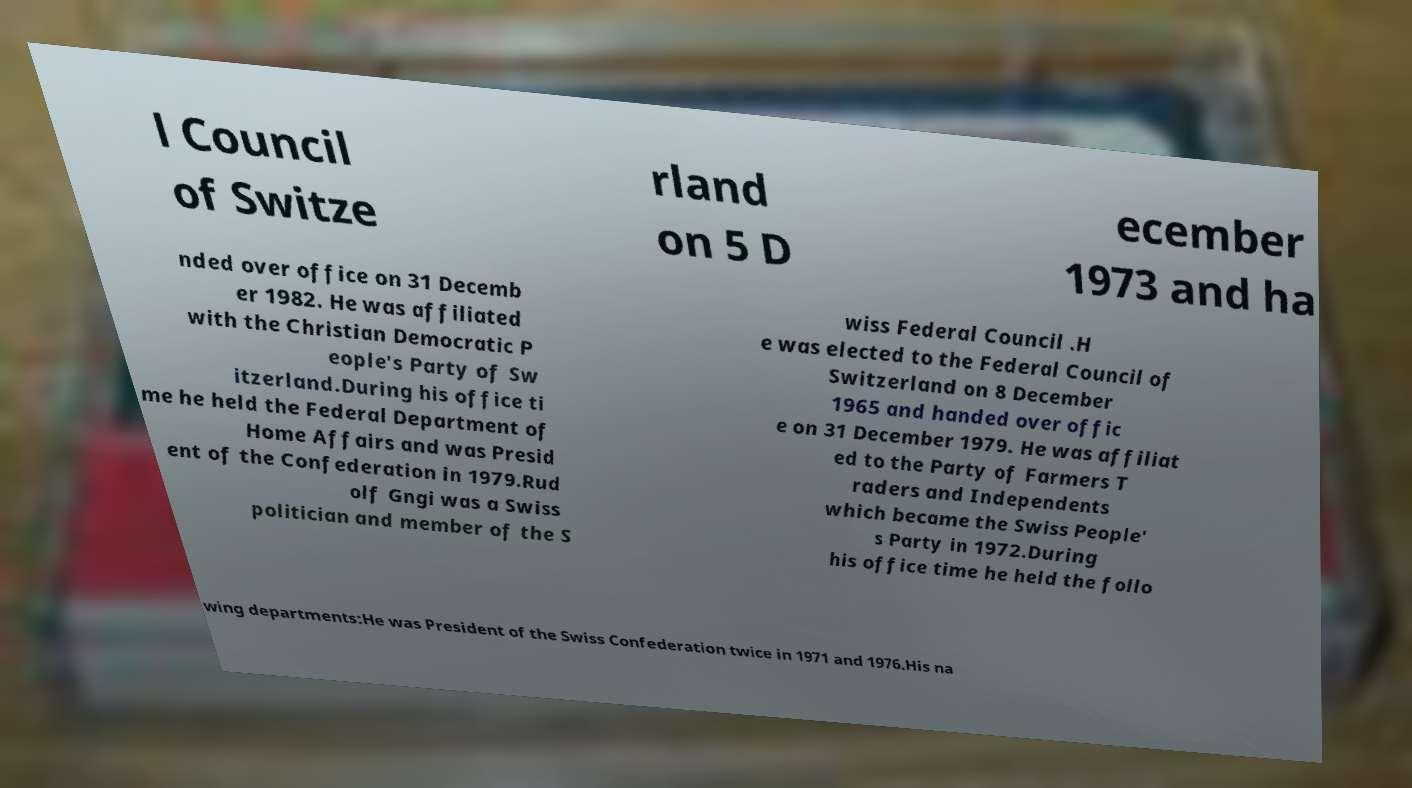There's text embedded in this image that I need extracted. Can you transcribe it verbatim? l Council of Switze rland on 5 D ecember 1973 and ha nded over office on 31 Decemb er 1982. He was affiliated with the Christian Democratic P eople's Party of Sw itzerland.During his office ti me he held the Federal Department of Home Affairs and was Presid ent of the Confederation in 1979.Rud olf Gngi was a Swiss politician and member of the S wiss Federal Council .H e was elected to the Federal Council of Switzerland on 8 December 1965 and handed over offic e on 31 December 1979. He was affiliat ed to the Party of Farmers T raders and Independents which became the Swiss People' s Party in 1972.During his office time he held the follo wing departments:He was President of the Swiss Confederation twice in 1971 and 1976.His na 